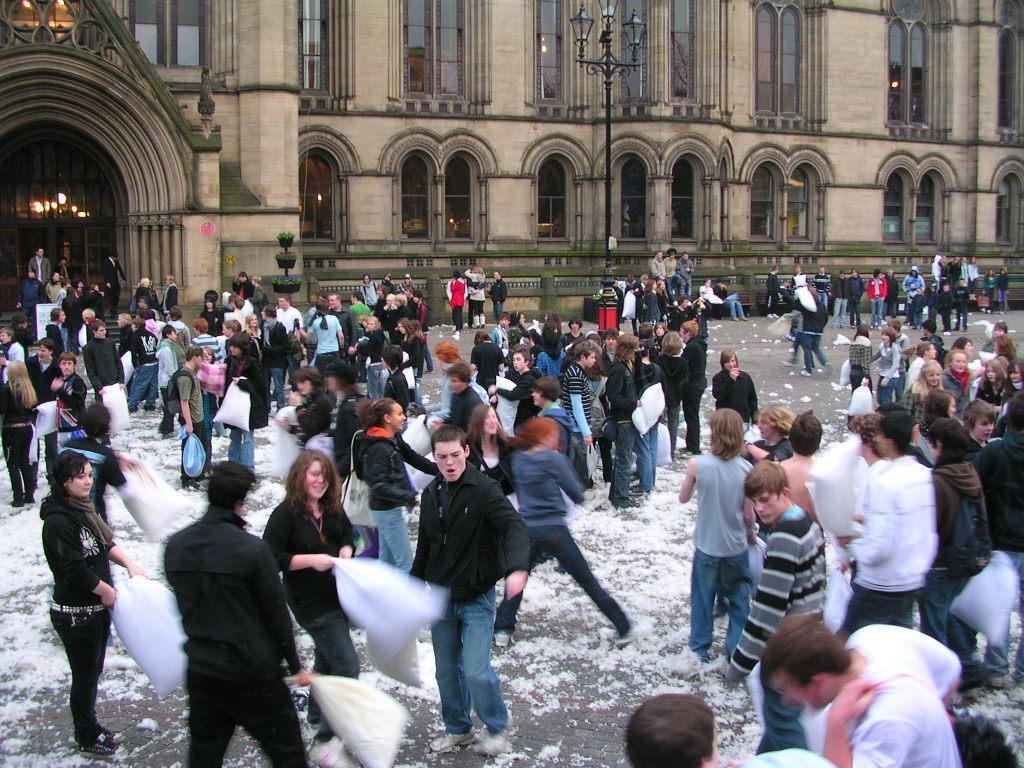Describe this image in one or two sentences. In this image we can see a group of people are standing on the road and holding plastic covers in the hand, in front there is a building, there are windows, there is a lamp, there are lights. 